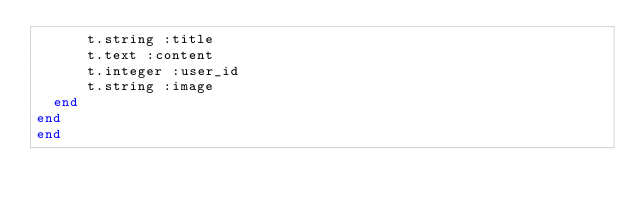Convert code to text. <code><loc_0><loc_0><loc_500><loc_500><_Ruby_>      t.string :title
      t.text :content
      t.integer :user_id
      t.string :image 
  end
end
end
</code> 